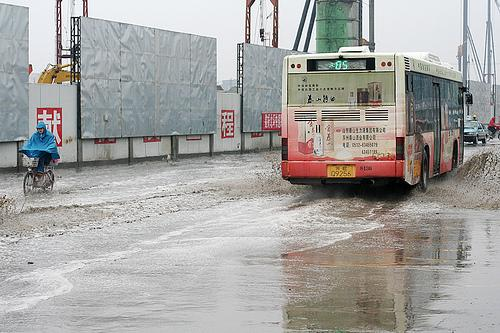Which object is in the greatest danger? Please explain your reasoning. cyclist. The water is very deep for the bike. 